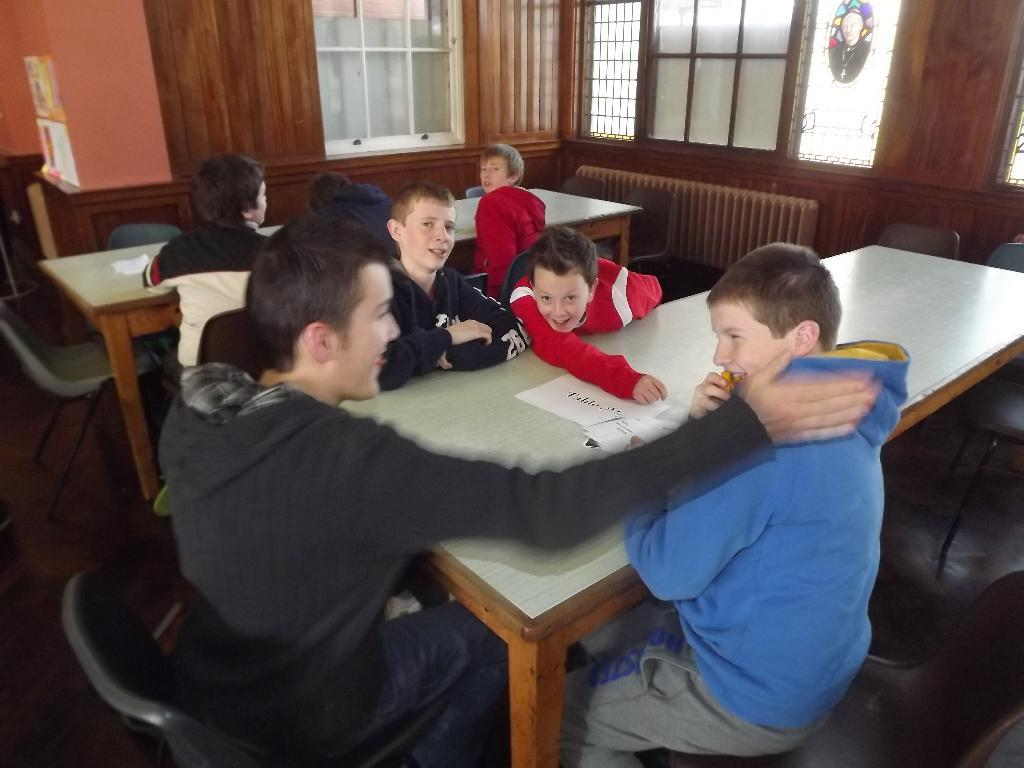What are the people in the image doing? The people in the image are sitting around a table. What is the mood or expression of the people in the image? The people in the image are smiling. What can be seen in the background of the image? There is a window and a wall in the background of the image. What type of hat is the person in the image wearing? There is no hat visible in the image. How much does the table weigh in the image? The weight of the table cannot be determined from the image. 